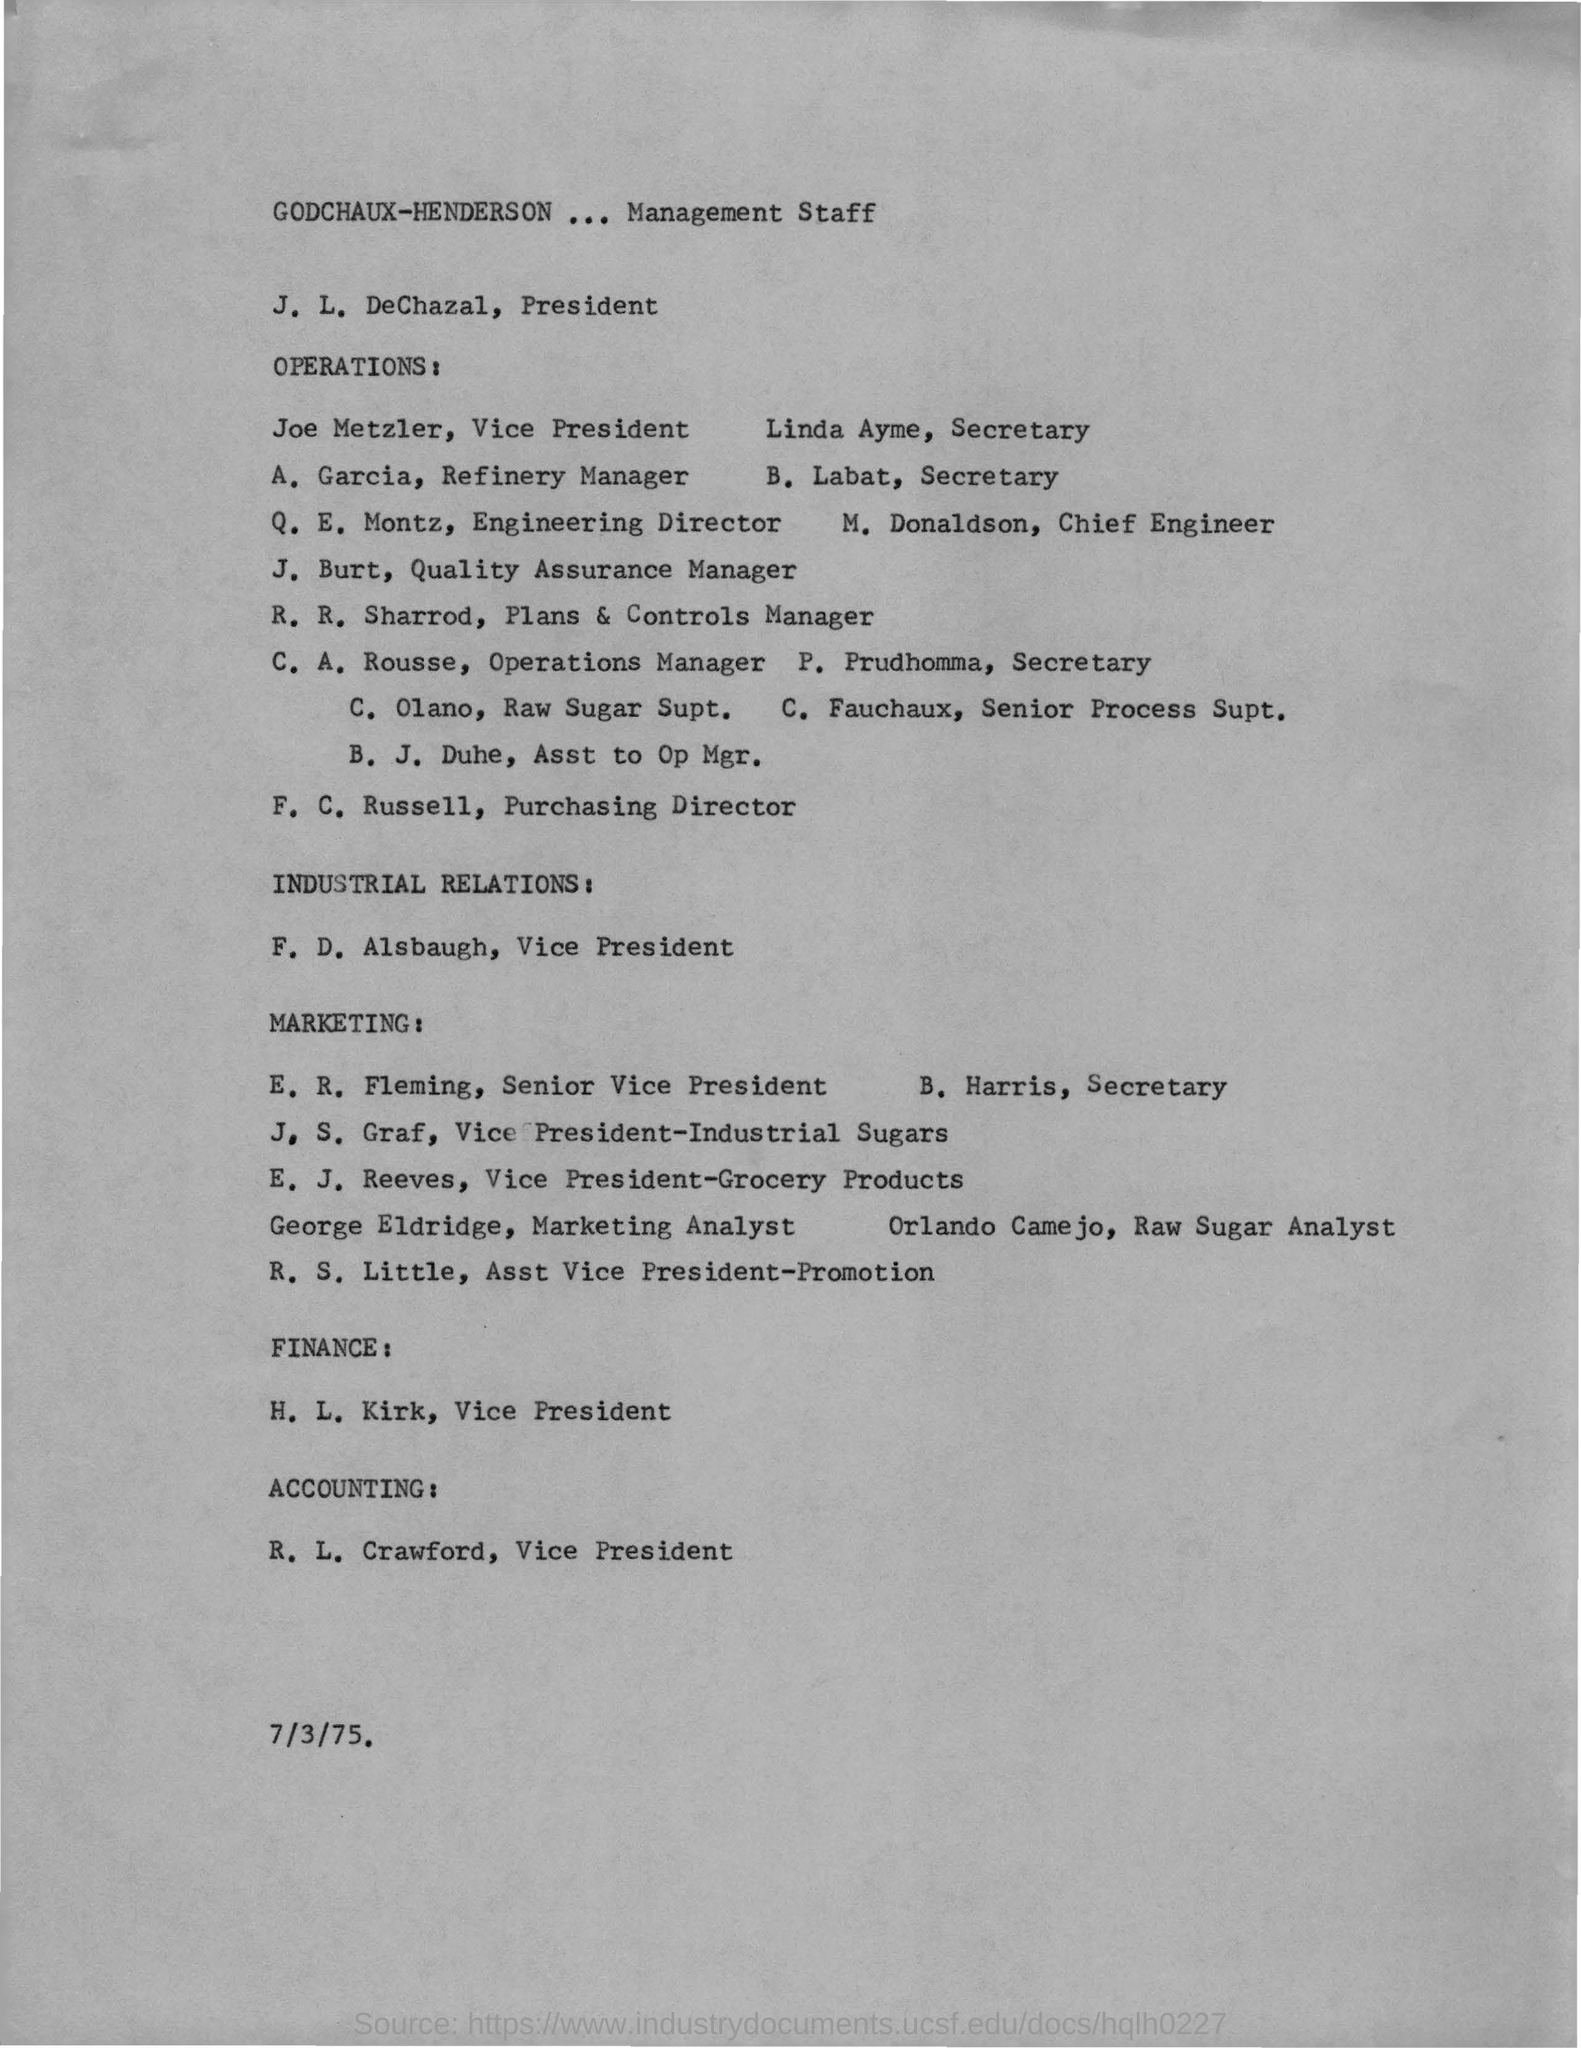Point out several critical features in this image. R. L. Crawford is the Vice President of Accounting. Joe Metzler is the Vice President of Operations. F. D. Alsbaugh is the Vice President of Industrial Relations. 